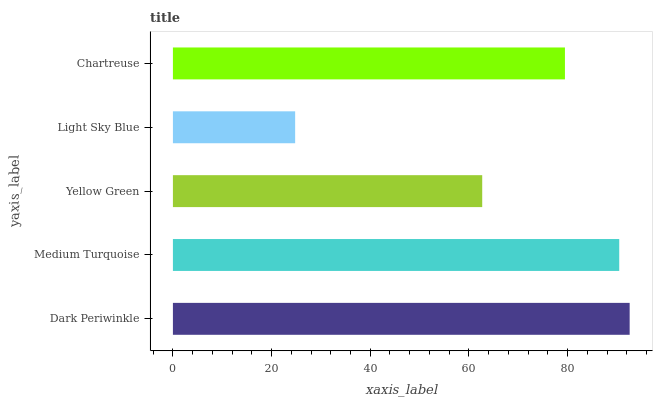Is Light Sky Blue the minimum?
Answer yes or no. Yes. Is Dark Periwinkle the maximum?
Answer yes or no. Yes. Is Medium Turquoise the minimum?
Answer yes or no. No. Is Medium Turquoise the maximum?
Answer yes or no. No. Is Dark Periwinkle greater than Medium Turquoise?
Answer yes or no. Yes. Is Medium Turquoise less than Dark Periwinkle?
Answer yes or no. Yes. Is Medium Turquoise greater than Dark Periwinkle?
Answer yes or no. No. Is Dark Periwinkle less than Medium Turquoise?
Answer yes or no. No. Is Chartreuse the high median?
Answer yes or no. Yes. Is Chartreuse the low median?
Answer yes or no. Yes. Is Dark Periwinkle the high median?
Answer yes or no. No. Is Medium Turquoise the low median?
Answer yes or no. No. 